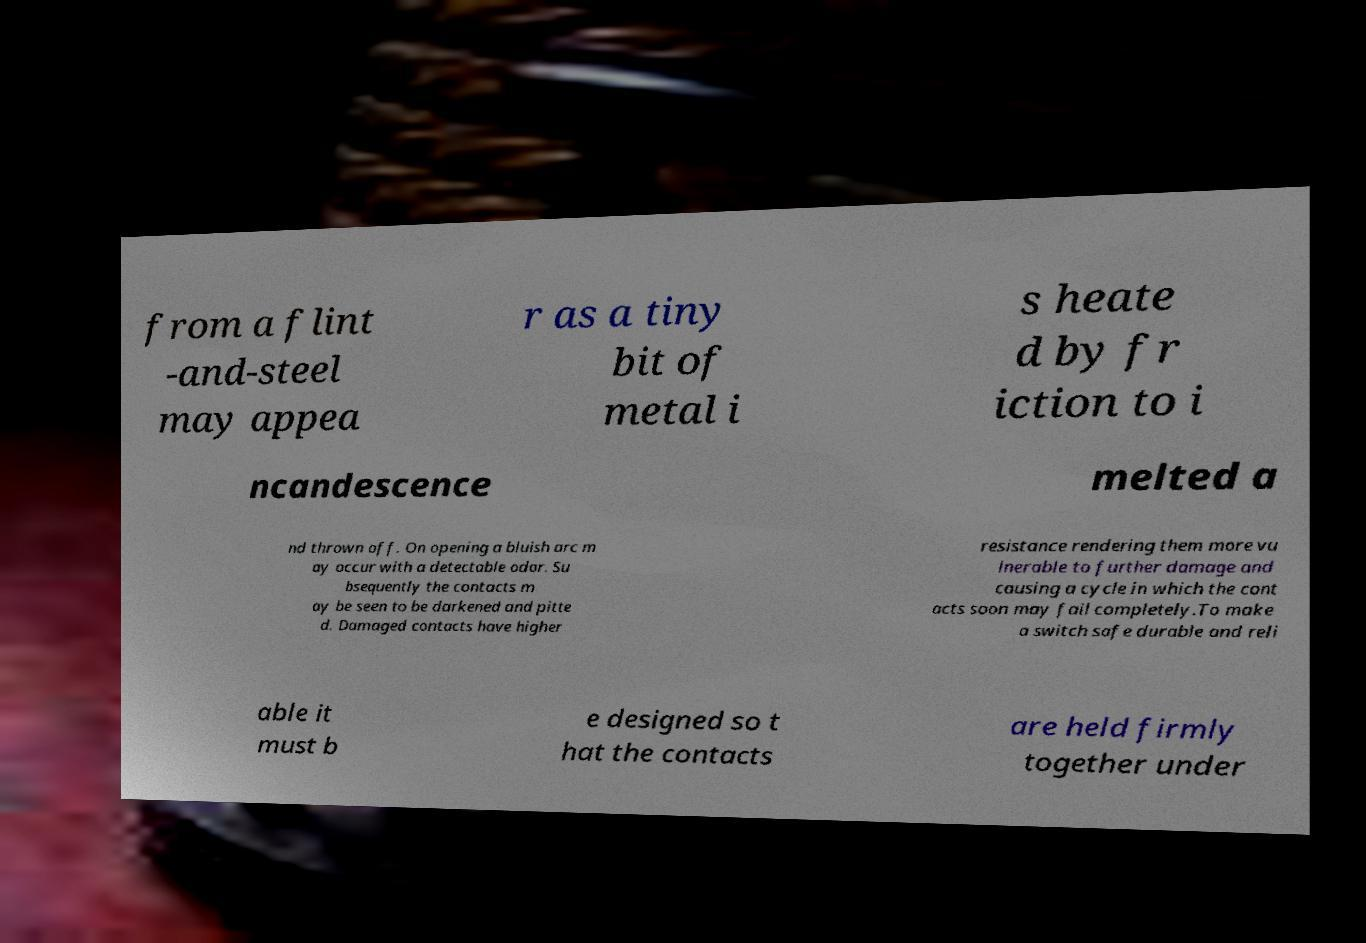Can you read and provide the text displayed in the image?This photo seems to have some interesting text. Can you extract and type it out for me? from a flint -and-steel may appea r as a tiny bit of metal i s heate d by fr iction to i ncandescence melted a nd thrown off. On opening a bluish arc m ay occur with a detectable odor. Su bsequently the contacts m ay be seen to be darkened and pitte d. Damaged contacts have higher resistance rendering them more vu lnerable to further damage and causing a cycle in which the cont acts soon may fail completely.To make a switch safe durable and reli able it must b e designed so t hat the contacts are held firmly together under 